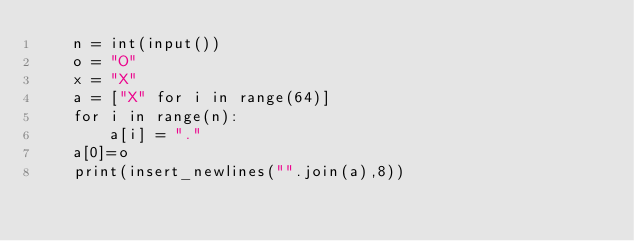Convert code to text. <code><loc_0><loc_0><loc_500><loc_500><_Python_>    n = int(input())
    o = "O"
    x = "X"
    a = ["X" for i in range(64)]
    for i in range(n):
        a[i] = "."
    a[0]=o
    print(insert_newlines("".join(a),8))
        
</code> 